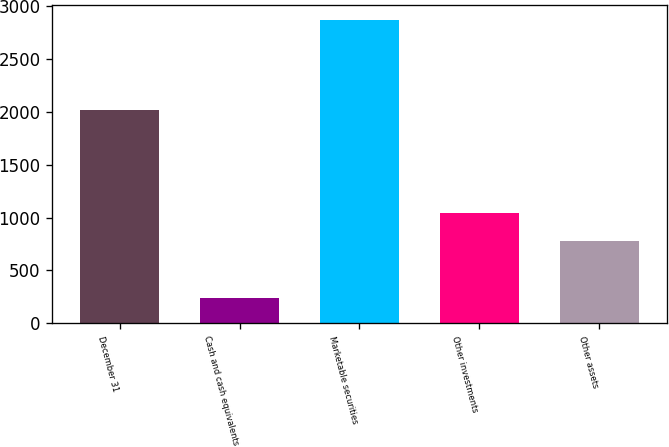Convert chart. <chart><loc_0><loc_0><loc_500><loc_500><bar_chart><fcel>December 31<fcel>Cash and cash equivalents<fcel>Marketable securities<fcel>Other investments<fcel>Other assets<nl><fcel>2013<fcel>245<fcel>2861<fcel>1039.6<fcel>778<nl></chart> 